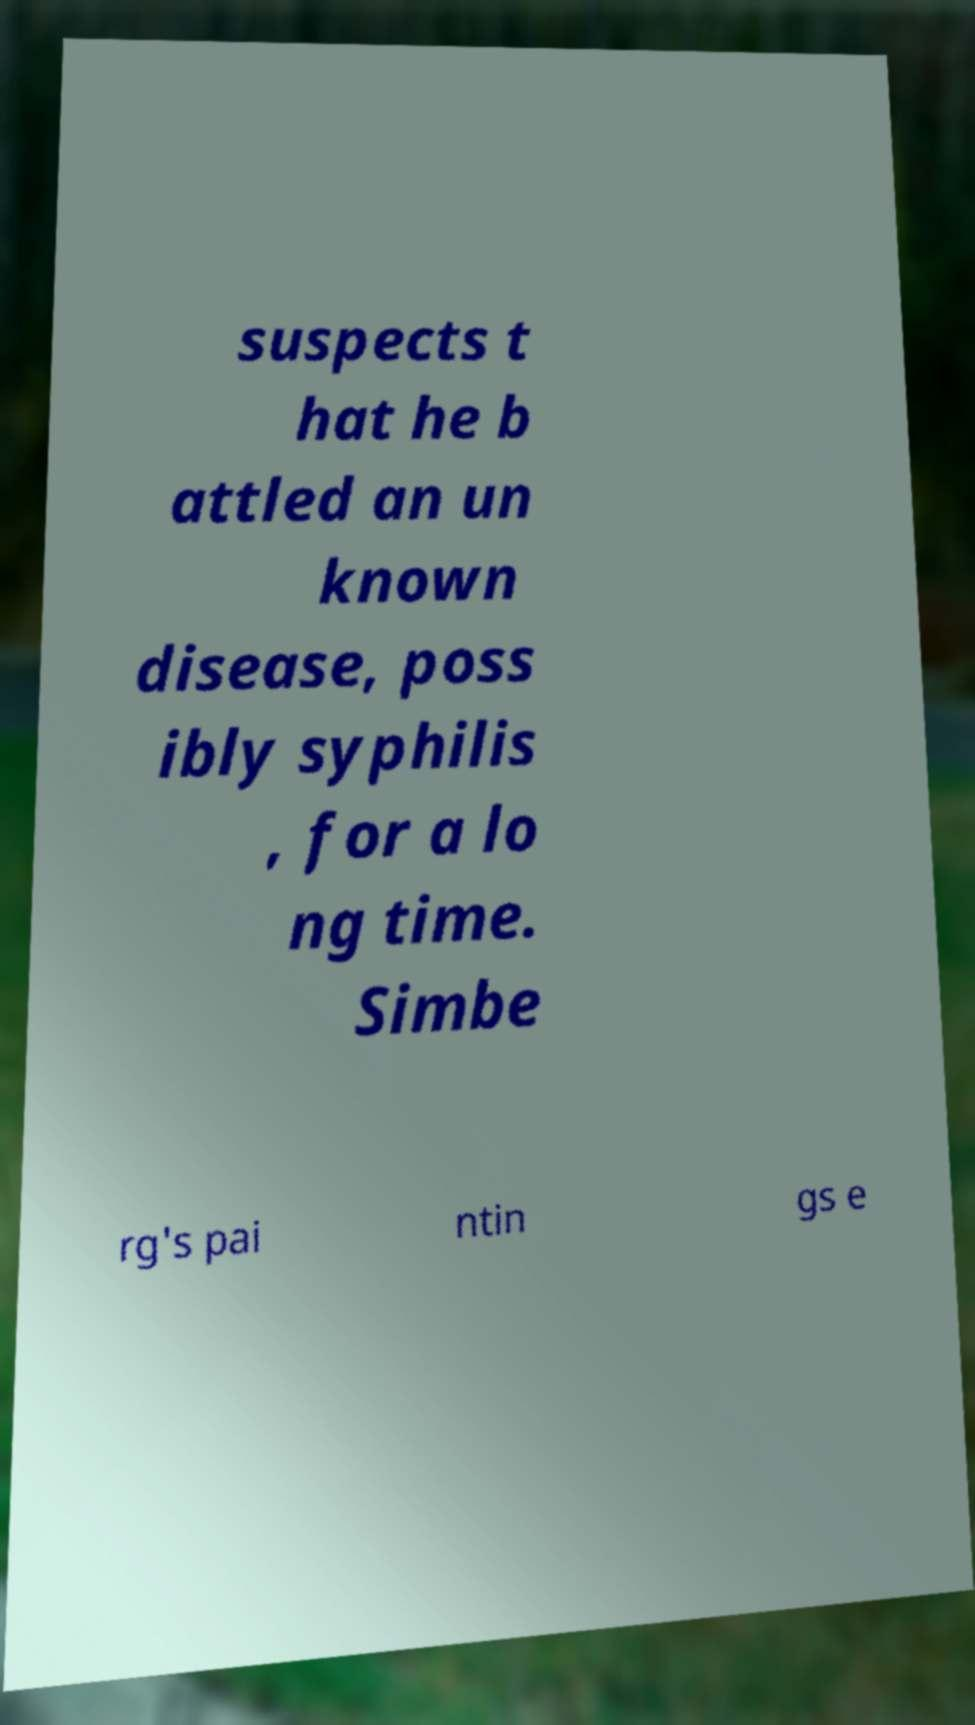Can you accurately transcribe the text from the provided image for me? suspects t hat he b attled an un known disease, poss ibly syphilis , for a lo ng time. Simbe rg's pai ntin gs e 